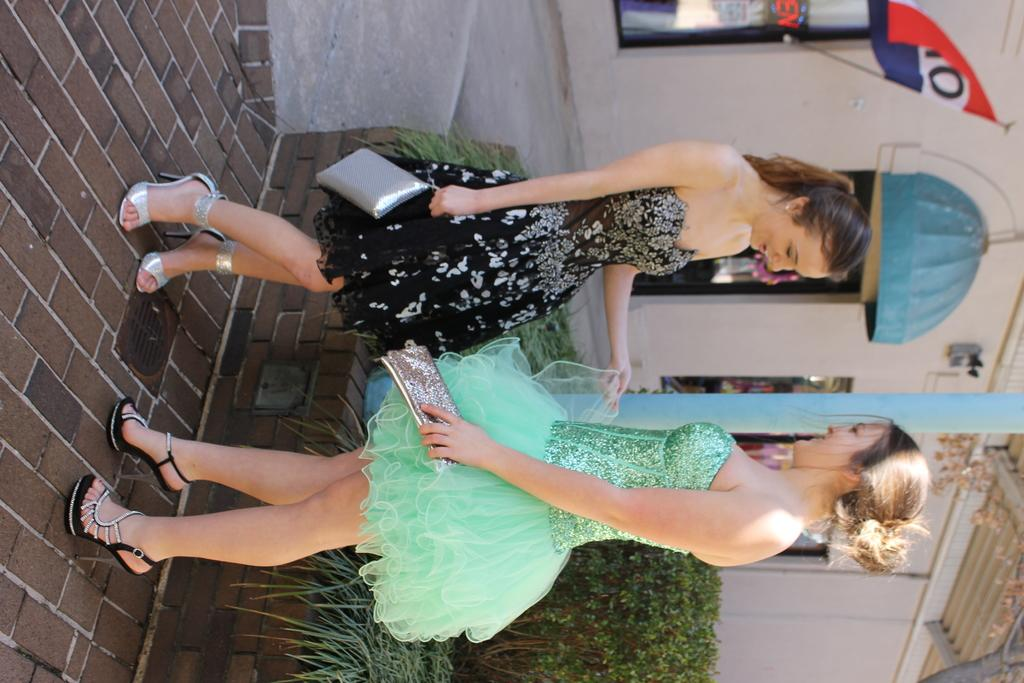How many people are in the image? There are two ladies standing in the center of the image. What are the ladies holding in the image? The ladies are holding wallets. What type of vegetation can be seen at the bottom of the image? There are bushes at the bottom of the image. What can be seen in the background of the image? There is a building and a flag in the background of the image. What type of growth can be seen on the ladies' heads in the image? There is no growth visible on the ladies' heads in the image. What nation does the flag in the background represent? The image does not provide enough information to determine which nation the flag represents. 